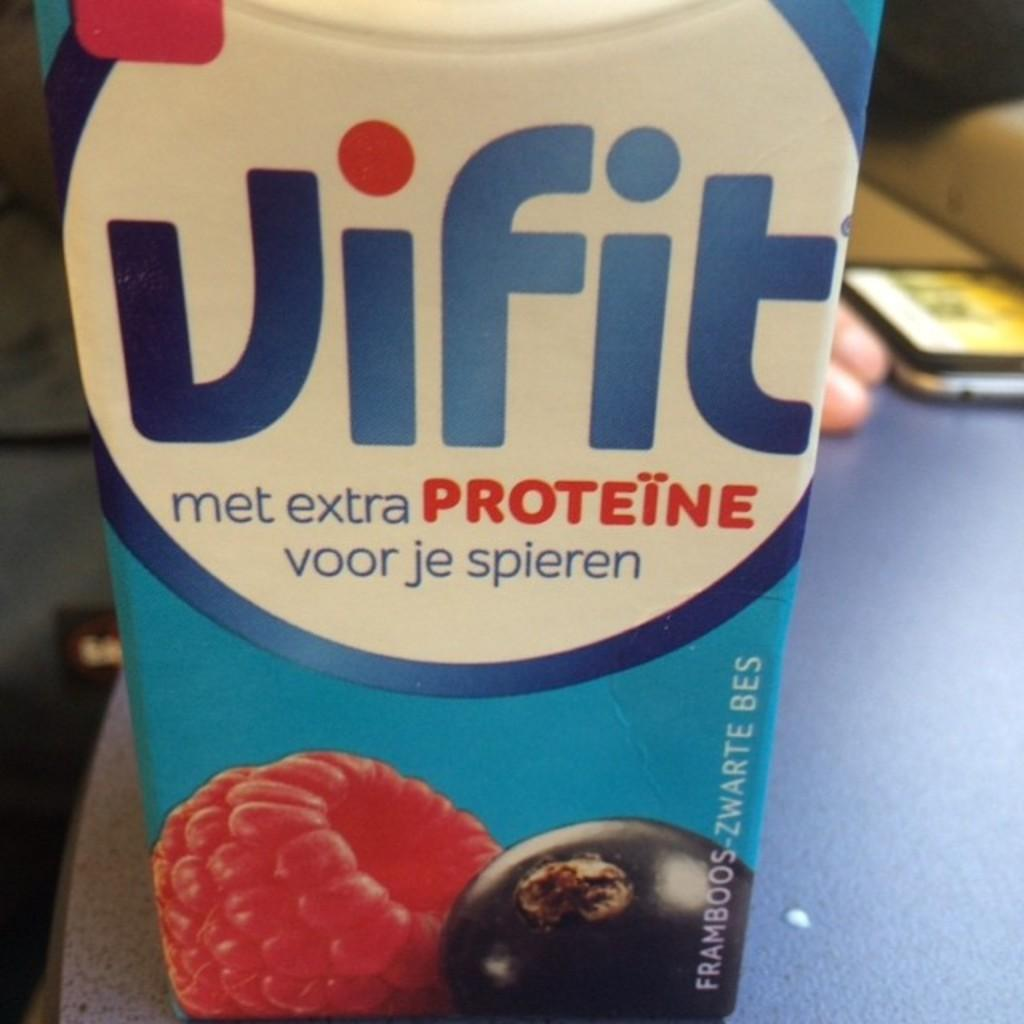Provide a one-sentence caption for the provided image. A carton of Vifit juice with extra proteine. 